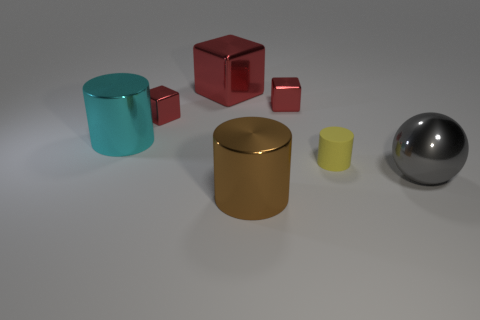Subtract all red cubes. How many were subtracted if there are1red cubes left? 2 Subtract all large red metal cubes. How many cubes are left? 2 Add 1 gray objects. How many objects exist? 8 Subtract 1 cubes. How many cubes are left? 2 Subtract all cylinders. How many objects are left? 4 Add 4 cyan cylinders. How many cyan cylinders exist? 5 Subtract 0 brown balls. How many objects are left? 7 Subtract all red blocks. Subtract all small yellow matte things. How many objects are left? 3 Add 1 large cyan cylinders. How many large cyan cylinders are left? 2 